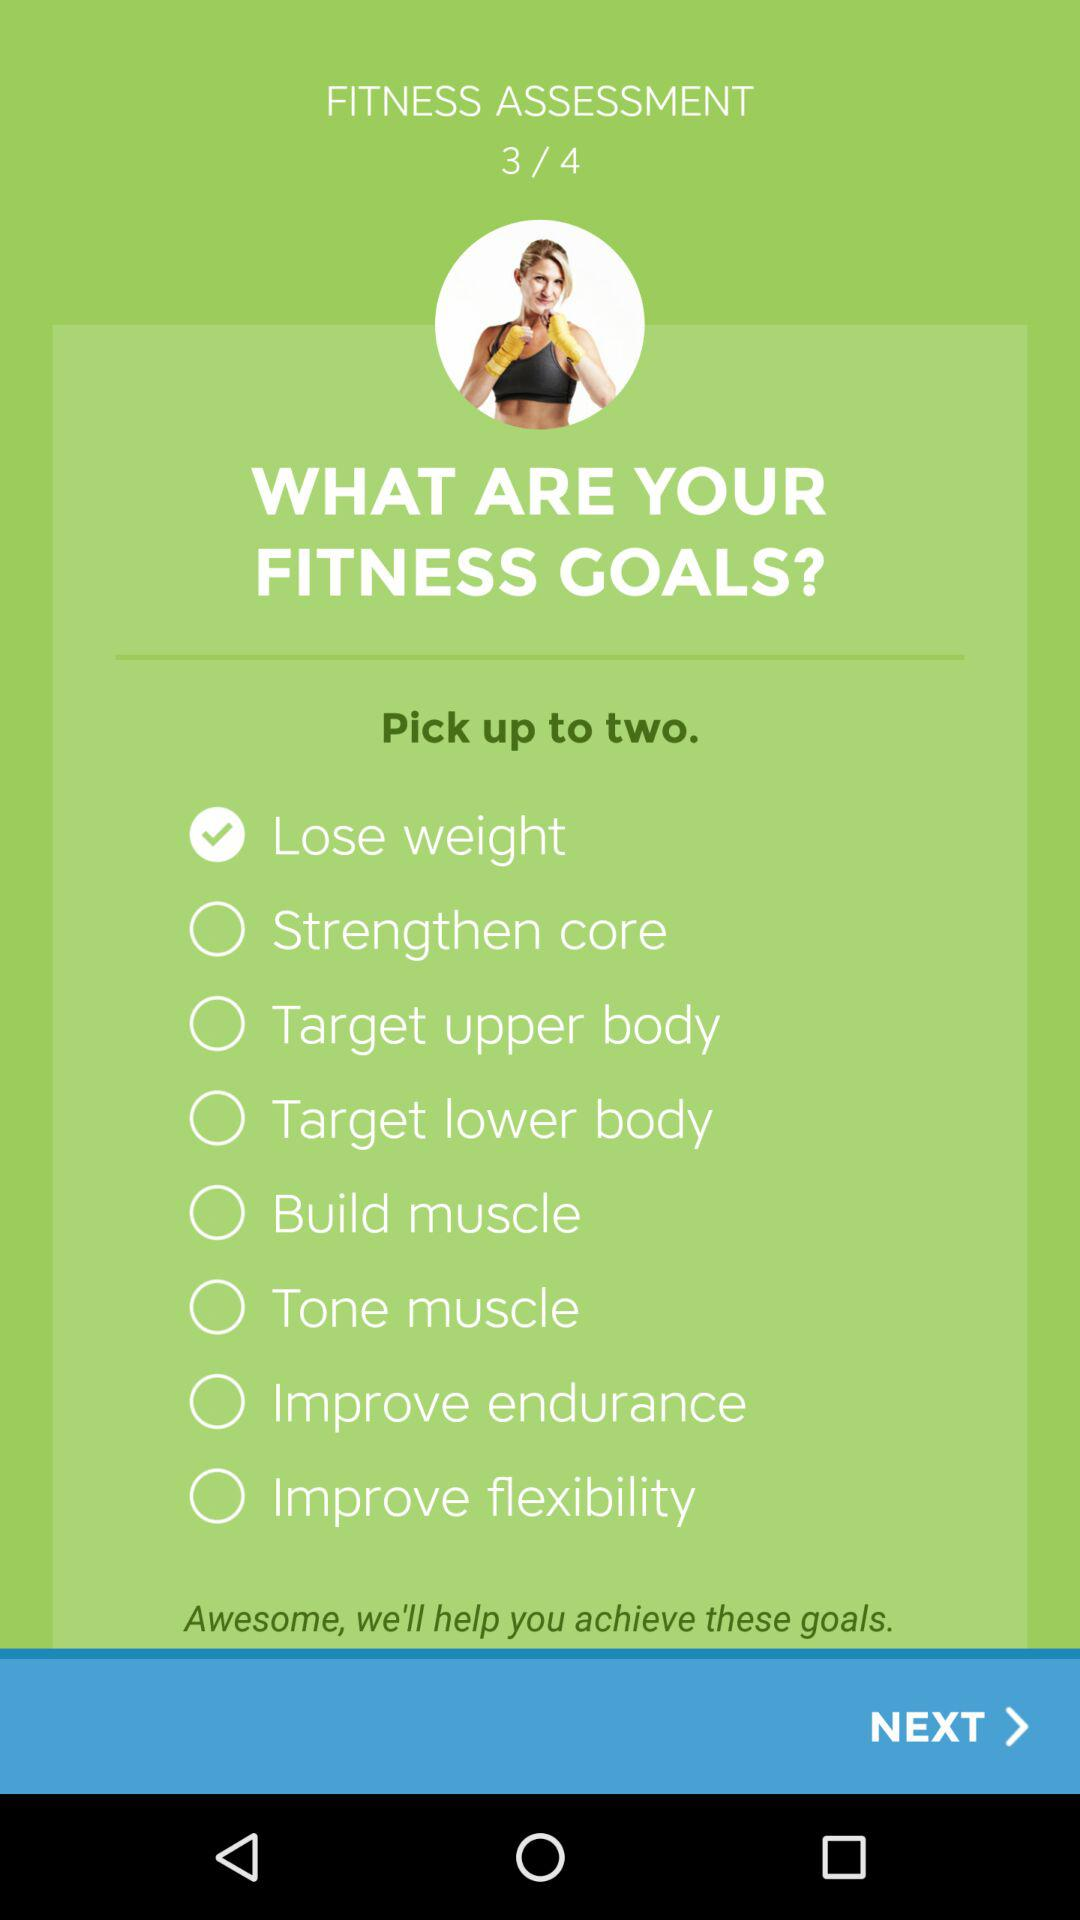How many exercises can I pick? You can pick up to two exercises. 